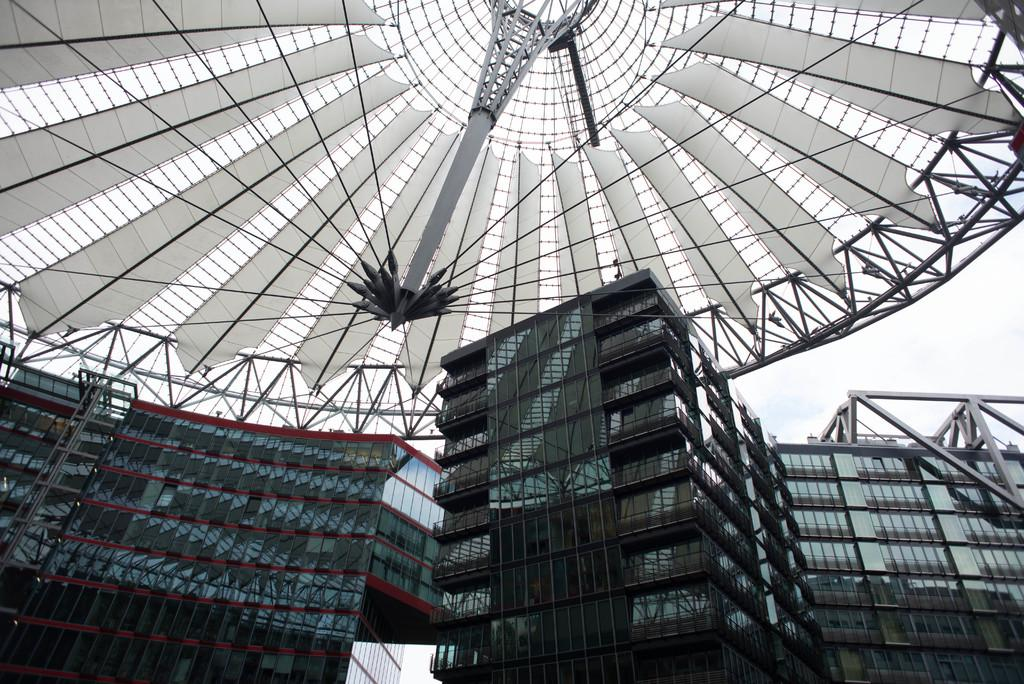What type of buildings can be seen in the foreground of the image? The fact states that there are buildings with glass windows in the foreground of the image. We start by identifying the main subject, which is the buildings. Then, we describe their specific features, such as the glass windows, iron frames, and glasses on the ceiling. Finally, we mention the sky visible on the right side of the image to give a sense of the setting. Absurd Question/Answer: Are there any dinosaurs visible in the image? No, there are no dinosaurs present in the image. What type of action can be seen taking place in the image? There is no specific action taking place in the image; it primarily features buildings with glass windows and the sky visible on the right side. 